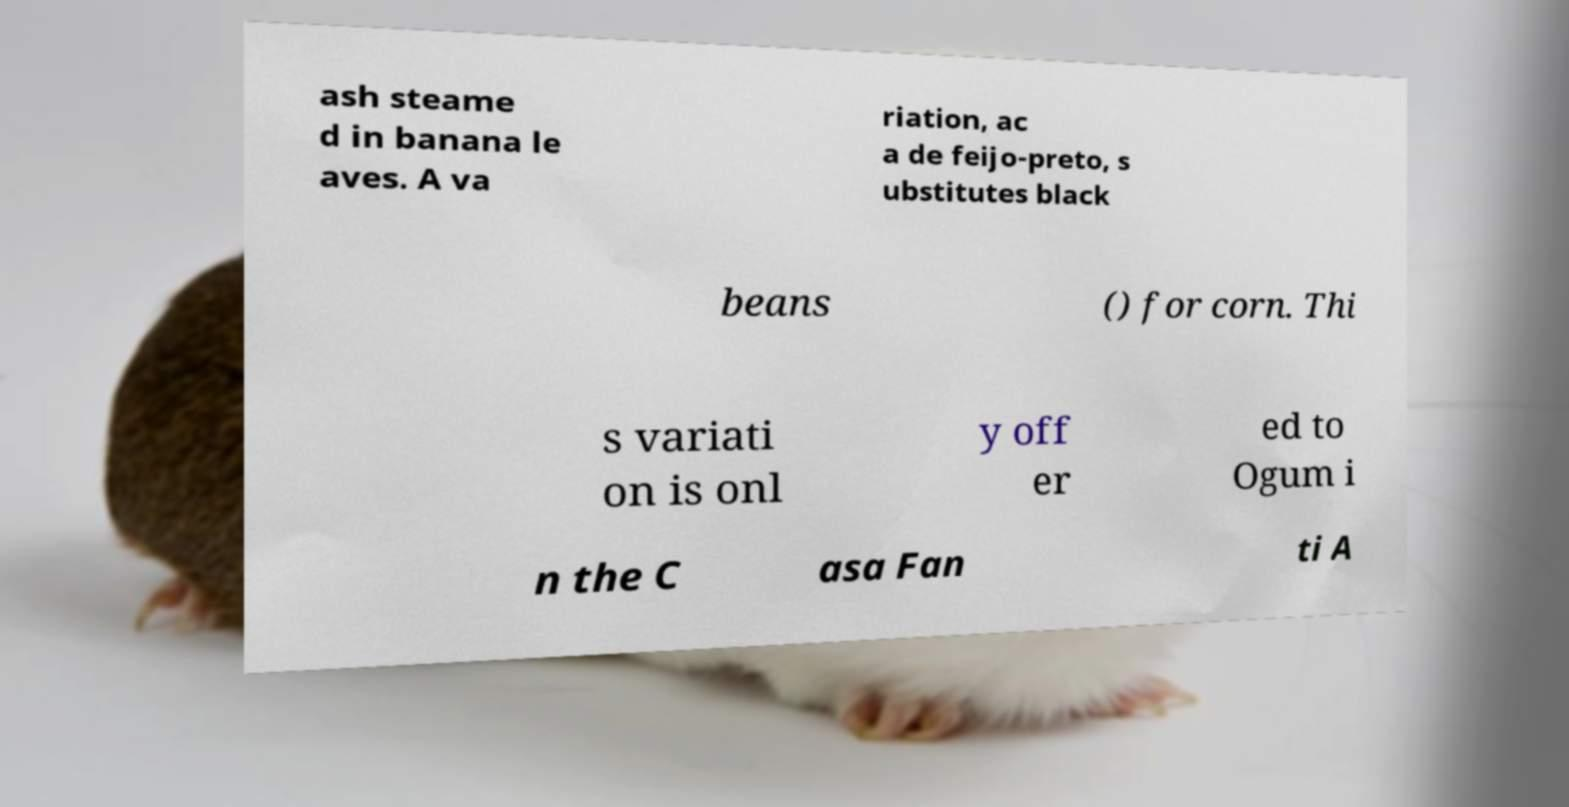I need the written content from this picture converted into text. Can you do that? ash steame d in banana le aves. A va riation, ac a de feijo-preto, s ubstitutes black beans () for corn. Thi s variati on is onl y off er ed to Ogum i n the C asa Fan ti A 